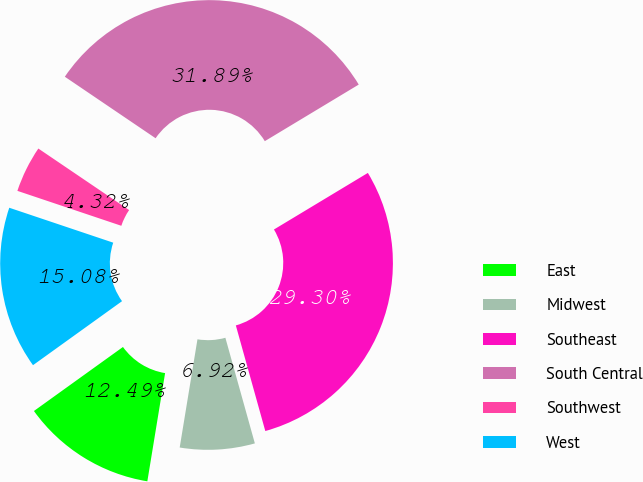Convert chart. <chart><loc_0><loc_0><loc_500><loc_500><pie_chart><fcel>East<fcel>Midwest<fcel>Southeast<fcel>South Central<fcel>Southwest<fcel>West<nl><fcel>12.49%<fcel>6.92%<fcel>29.3%<fcel>31.89%<fcel>4.32%<fcel>15.08%<nl></chart> 